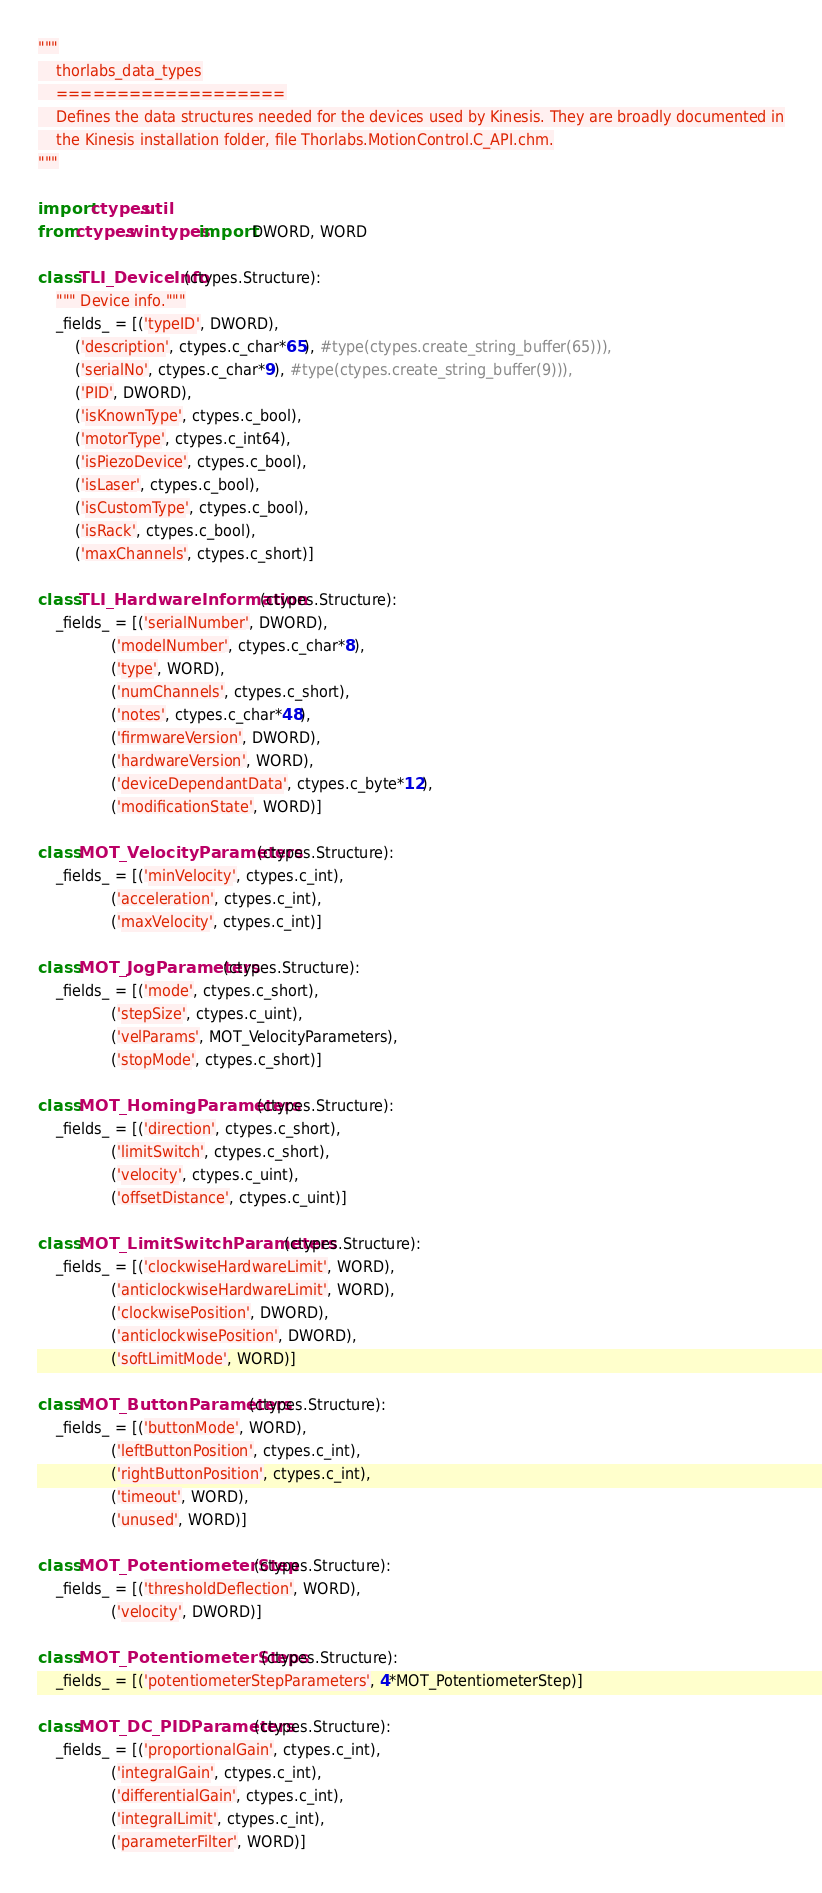Convert code to text. <code><loc_0><loc_0><loc_500><loc_500><_Python_>"""
    thorlabs_data_types
    ===================
    Defines the data structures needed for the devices used by Kinesis. They are broadly documented in
    the Kinesis installation folder, file Thorlabs.MotionControl.C_API.chm.
"""

import ctypes.util
from ctypes.wintypes import DWORD, WORD

class TLI_DeviceInfo(ctypes.Structure):
    """ Device info."""
    _fields_ = [('typeID', DWORD),
        ('description', ctypes.c_char*65), #type(ctypes.create_string_buffer(65))),
        ('serialNo', ctypes.c_char*9), #type(ctypes.create_string_buffer(9))),
        ('PID', DWORD),
        ('isKnownType', ctypes.c_bool),
        ('motorType', ctypes.c_int64),
        ('isPiezoDevice', ctypes.c_bool),
        ('isLaser', ctypes.c_bool),
        ('isCustomType', ctypes.c_bool),
        ('isRack', ctypes.c_bool),
        ('maxChannels', ctypes.c_short)]

class TLI_HardwareInformation(ctypes.Structure):
    _fields_ = [('serialNumber', DWORD),
                ('modelNumber', ctypes.c_char*8),
                ('type', WORD),
                ('numChannels', ctypes.c_short),
                ('notes', ctypes.c_char*48),
                ('firmwareVersion', DWORD),
                ('hardwareVersion', WORD),
                ('deviceDependantData', ctypes.c_byte*12),
                ('modificationState', WORD)]

class MOT_VelocityParameters(ctypes.Structure):
    _fields_ = [('minVelocity', ctypes.c_int),
                ('acceleration', ctypes.c_int),
                ('maxVelocity', ctypes.c_int)]

class MOT_JogParameters(ctypes.Structure):
    _fields_ = [('mode', ctypes.c_short),
                ('stepSize', ctypes.c_uint),
                ('velParams', MOT_VelocityParameters),
                ('stopMode', ctypes.c_short)]

class MOT_HomingParameters(ctypes.Structure):
    _fields_ = [('direction', ctypes.c_short),
                ('limitSwitch', ctypes.c_short),
                ('velocity', ctypes.c_uint),
                ('offsetDistance', ctypes.c_uint)]

class MOT_LimitSwitchParameters(ctypes.Structure):
    _fields_ = [('clockwiseHardwareLimit', WORD),
                ('anticlockwiseHardwareLimit', WORD),
                ('clockwisePosition', DWORD),
                ('anticlockwisePosition', DWORD),
                ('softLimitMode', WORD)]

class MOT_ButtonParameters(ctypes.Structure):
    _fields_ = [('buttonMode', WORD),
                ('leftButtonPosition', ctypes.c_int),
                ('rightButtonPosition', ctypes.c_int),
                ('timeout', WORD),
                ('unused', WORD)]

class MOT_PotentiometerStep(ctypes.Structure):
    _fields_ = [('thresholdDeflection', WORD),
                ('velocity', DWORD)]

class MOT_PotentiometerSteps(ctypes.Structure):
    _fields_ = [('potentiometerStepParameters', 4*MOT_PotentiometerStep)]

class MOT_DC_PIDParameters(ctypes.Structure):
    _fields_ = [('proportionalGain', ctypes.c_int),
                ('integralGain', ctypes.c_int),
                ('differentialGain', ctypes.c_int),
                ('integralLimit', ctypes.c_int),
                ('parameterFilter', WORD)]</code> 